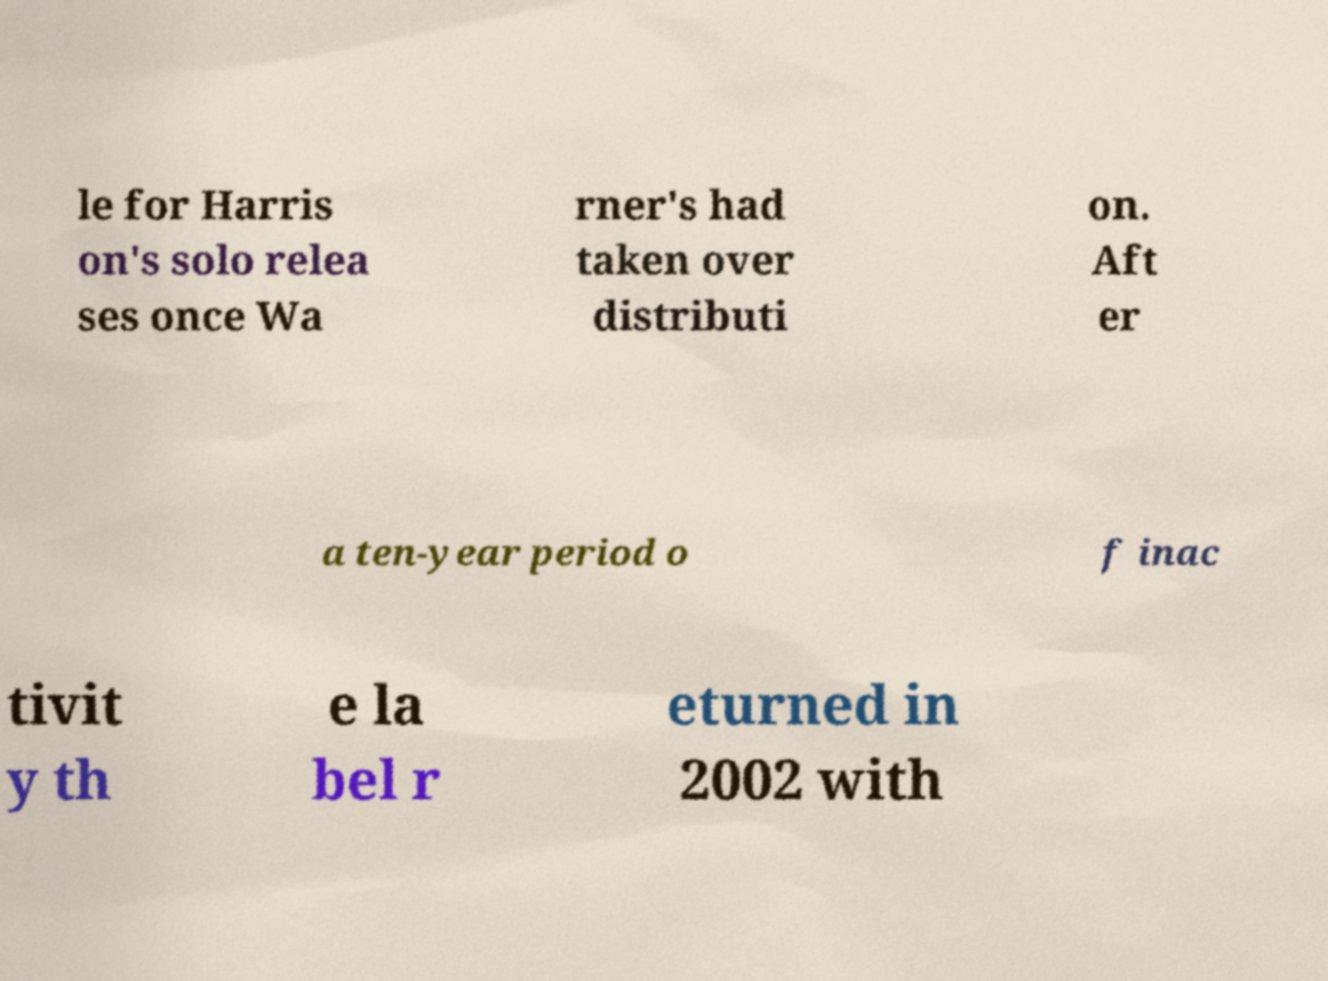Could you assist in decoding the text presented in this image and type it out clearly? le for Harris on's solo relea ses once Wa rner's had taken over distributi on. Aft er a ten-year period o f inac tivit y th e la bel r eturned in 2002 with 